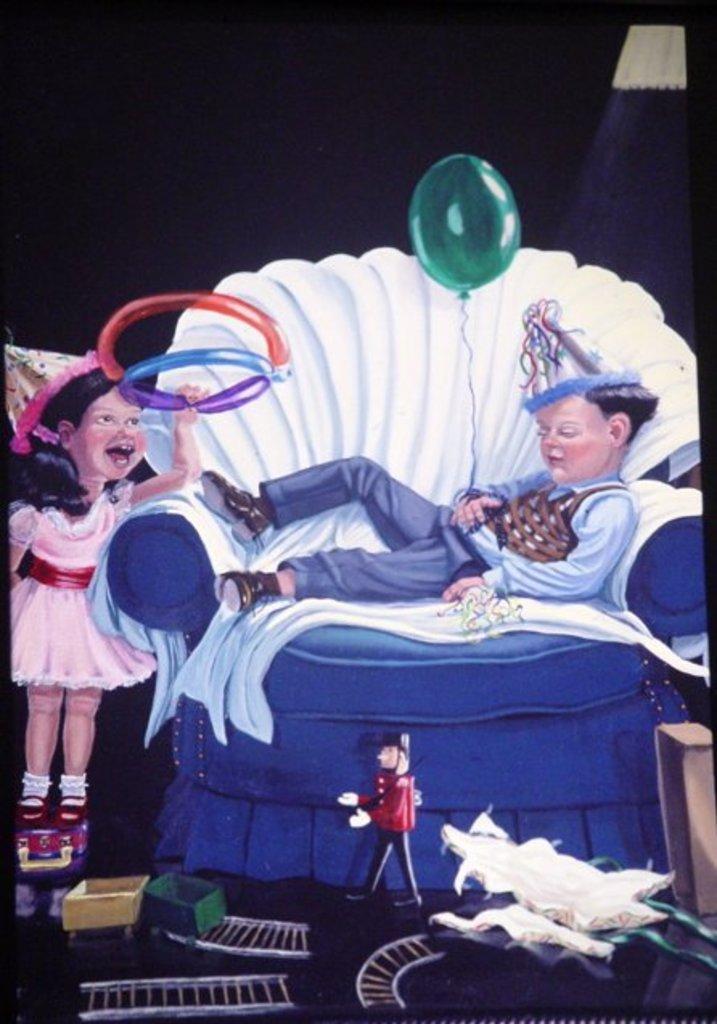How would you summarize this image in a sentence or two? In this picture we can see cartoon picture of a boy and girl, in this we can see he is lying on the sofa and he is holding a balloon. 